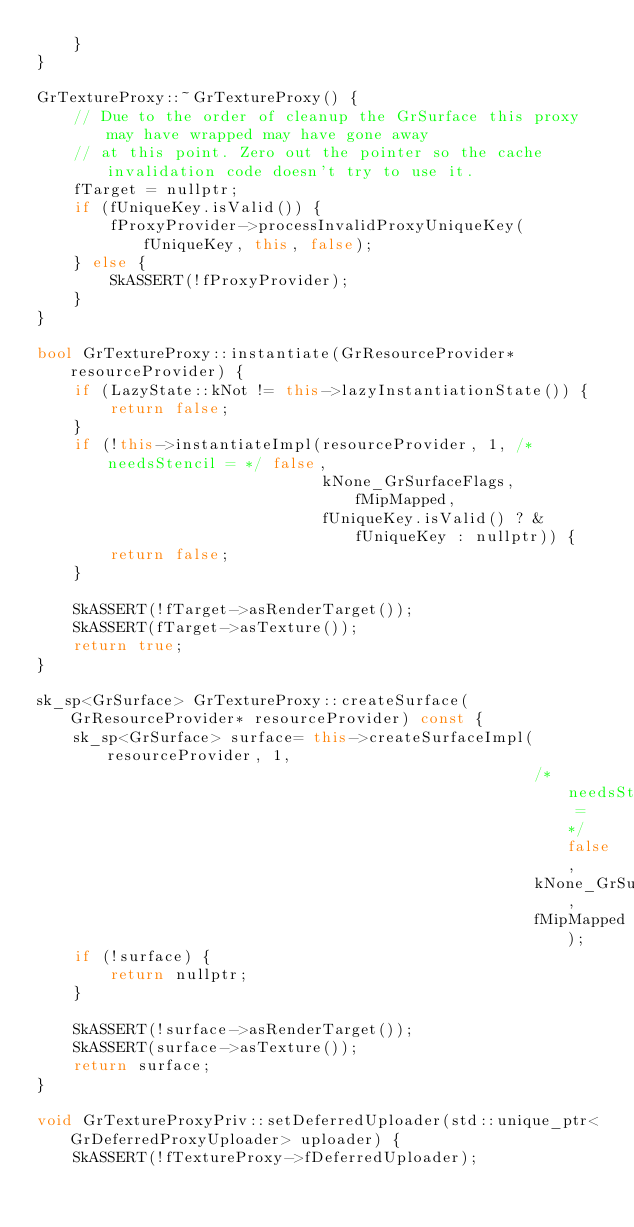Convert code to text. <code><loc_0><loc_0><loc_500><loc_500><_C++_>    }
}

GrTextureProxy::~GrTextureProxy() {
    // Due to the order of cleanup the GrSurface this proxy may have wrapped may have gone away
    // at this point. Zero out the pointer so the cache invalidation code doesn't try to use it.
    fTarget = nullptr;
    if (fUniqueKey.isValid()) {
        fProxyProvider->processInvalidProxyUniqueKey(fUniqueKey, this, false);
    } else {
        SkASSERT(!fProxyProvider);
    }
}

bool GrTextureProxy::instantiate(GrResourceProvider* resourceProvider) {
    if (LazyState::kNot != this->lazyInstantiationState()) {
        return false;
    }
    if (!this->instantiateImpl(resourceProvider, 1, /* needsStencil = */ false,
                               kNone_GrSurfaceFlags, fMipMapped,
                               fUniqueKey.isValid() ? &fUniqueKey : nullptr)) {
        return false;
    }

    SkASSERT(!fTarget->asRenderTarget());
    SkASSERT(fTarget->asTexture());
    return true;
}

sk_sp<GrSurface> GrTextureProxy::createSurface(GrResourceProvider* resourceProvider) const {
    sk_sp<GrSurface> surface= this->createSurfaceImpl(resourceProvider, 1,
                                                      /* needsStencil = */ false,
                                                      kNone_GrSurfaceFlags,
                                                      fMipMapped);
    if (!surface) {
        return nullptr;
    }

    SkASSERT(!surface->asRenderTarget());
    SkASSERT(surface->asTexture());
    return surface;
}

void GrTextureProxyPriv::setDeferredUploader(std::unique_ptr<GrDeferredProxyUploader> uploader) {
    SkASSERT(!fTextureProxy->fDeferredUploader);</code> 